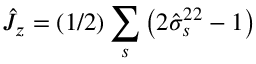<formula> <loc_0><loc_0><loc_500><loc_500>\hat { J } _ { z } = ( 1 / 2 ) \sum _ { s } \left ( 2 \hat { \sigma } _ { s } ^ { 2 2 } - 1 \right )</formula> 